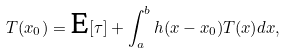Convert formula to latex. <formula><loc_0><loc_0><loc_500><loc_500>T ( x _ { 0 } ) = \text {E} [ \tau ] + \int _ { a } ^ { b } h ( x - x _ { 0 } ) T ( x ) d x ,</formula> 